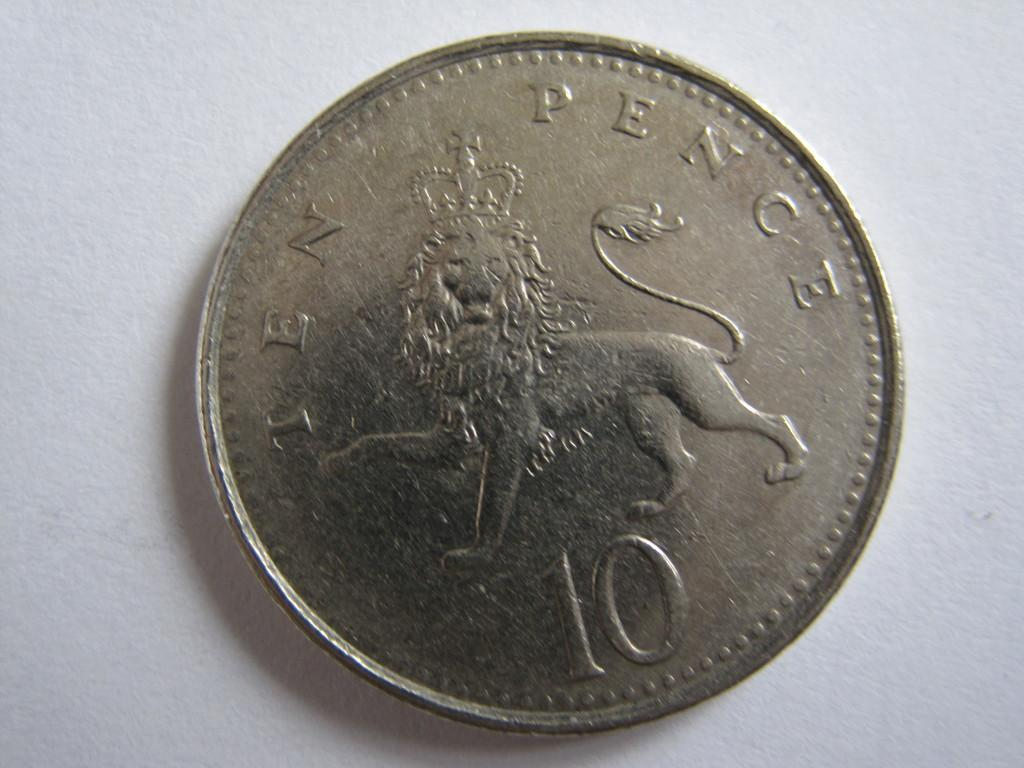<image>
Provide a brief description of the given image. A ten pence coin featuring a lion wearing a crown. 